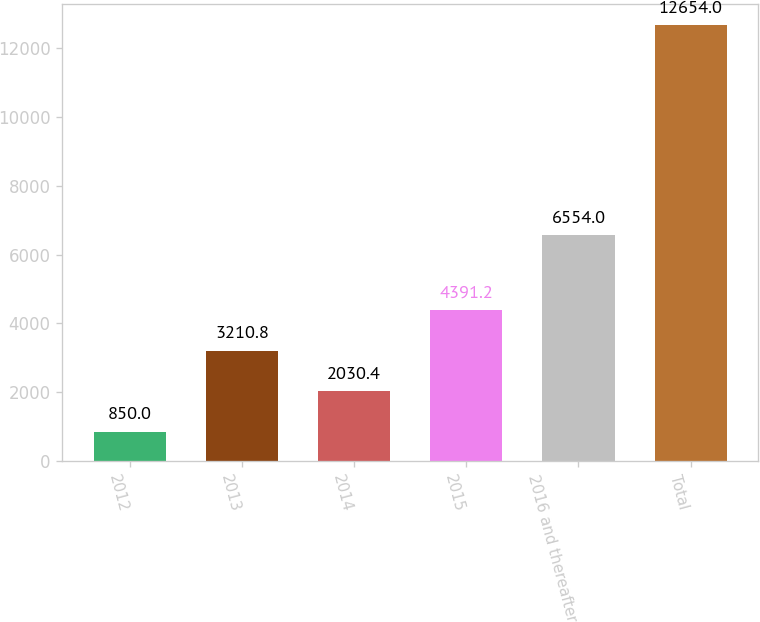Convert chart to OTSL. <chart><loc_0><loc_0><loc_500><loc_500><bar_chart><fcel>2012<fcel>2013<fcel>2014<fcel>2015<fcel>2016 and thereafter<fcel>Total<nl><fcel>850<fcel>3210.8<fcel>2030.4<fcel>4391.2<fcel>6554<fcel>12654<nl></chart> 